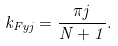<formula> <loc_0><loc_0><loc_500><loc_500>k _ { F y j } = \frac { \pi j } { N + 1 } .</formula> 